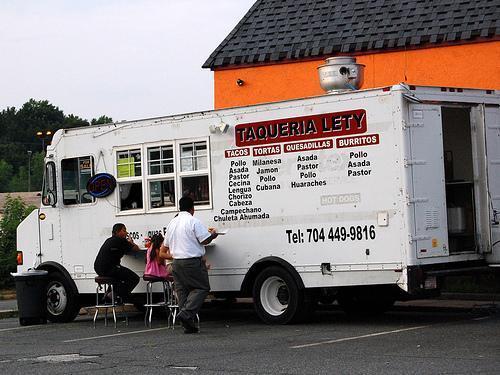How many people are in this picture?
Give a very brief answer. 3. How many different types of ice cream is there?
Give a very brief answer. 0. How many people can you see?
Give a very brief answer. 1. 